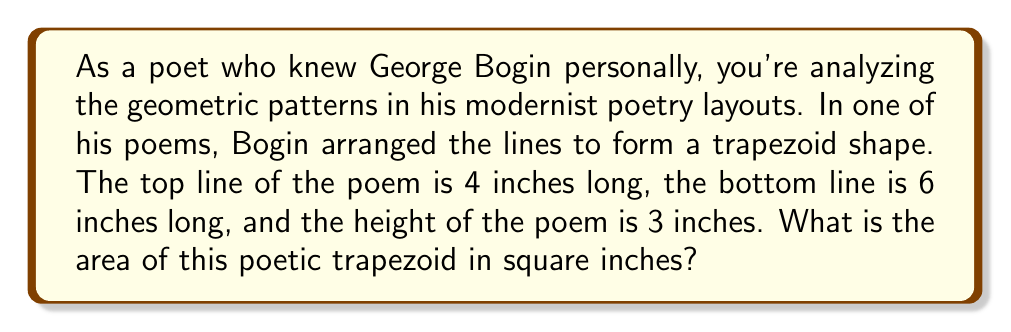What is the answer to this math problem? To solve this problem, we'll use the formula for the area of a trapezoid:

$$A = \frac{1}{2}(b_1 + b_2)h$$

Where:
$A$ = area of the trapezoid
$b_1$ = length of one parallel side (top line)
$b_2$ = length of the other parallel side (bottom line)
$h$ = height of the trapezoid

Given:
$b_1 = 4$ inches (top line)
$b_2 = 6$ inches (bottom line)
$h = 3$ inches (height)

Let's substitute these values into the formula:

$$A = \frac{1}{2}(4 + 6) \cdot 3$$

Simplifying:
$$A = \frac{1}{2}(10) \cdot 3$$
$$A = 5 \cdot 3$$
$$A = 15$$

Therefore, the area of the poetic trapezoid is 15 square inches.

[asy]
unitsize(0.5cm);
draw((0,0)--(6,0)--(4,3)--(0,3)--cycle);
label("6\"", (3,0), S);
label("4\"", (2,3), N);
label("3\"", (0,1.5), W);
[/asy]
Answer: 15 square inches 